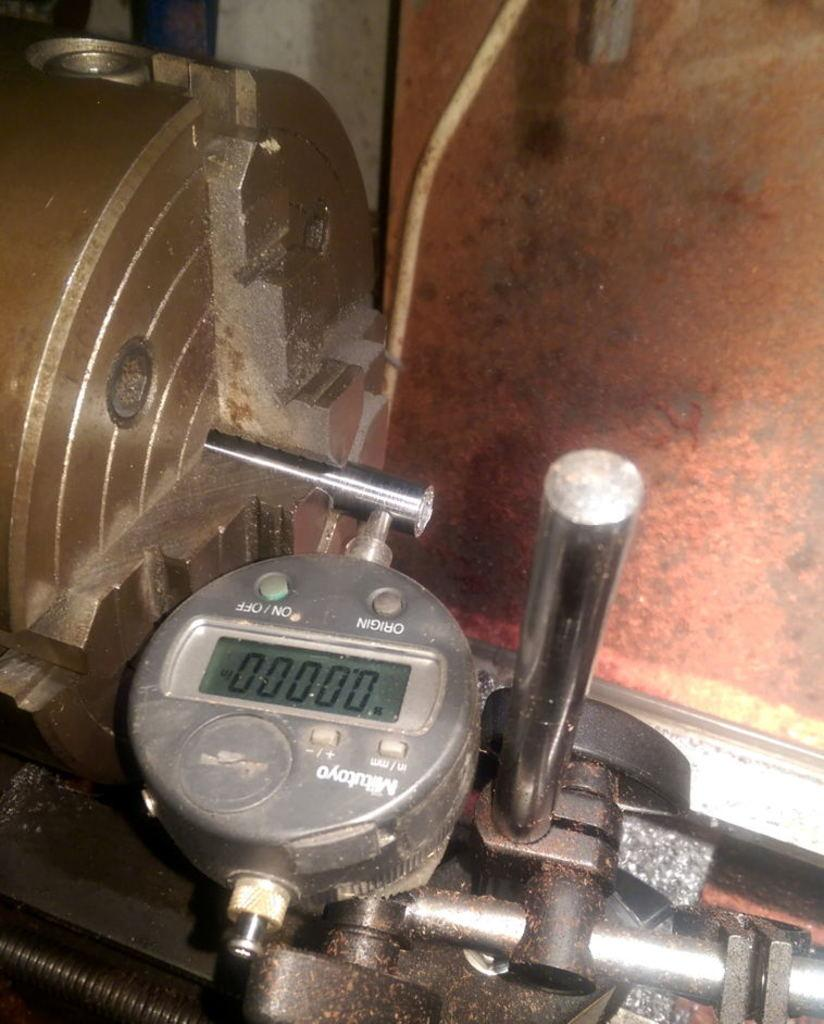What is located at the bottom of the image? There is an engine at the bottom of the image. What can be seen in the background of the image? There is a wall in the background of the image. What type of vessel is being discussed by the committee in the image? There is no vessel or committee present in the image; it only features an engine and a wall in the background. 